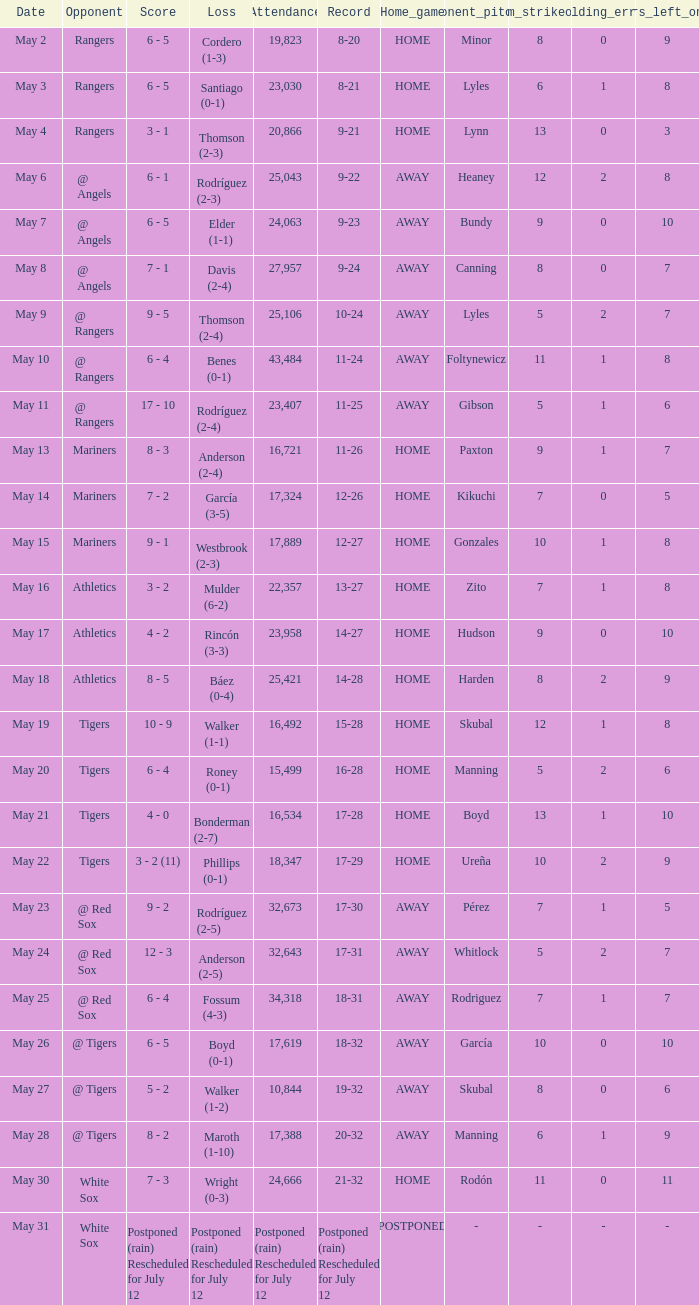What was the Indians record during the game that had 19,823 fans attending? 8-20. 